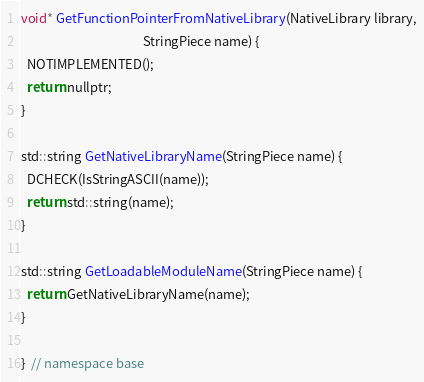<code> <loc_0><loc_0><loc_500><loc_500><_ObjectiveC_>
void* GetFunctionPointerFromNativeLibrary(NativeLibrary library,
                                          StringPiece name) {
  NOTIMPLEMENTED();
  return nullptr;
}

std::string GetNativeLibraryName(StringPiece name) {
  DCHECK(IsStringASCII(name));
  return std::string(name);
}

std::string GetLoadableModuleName(StringPiece name) {
  return GetNativeLibraryName(name);
}

}  // namespace base
</code> 